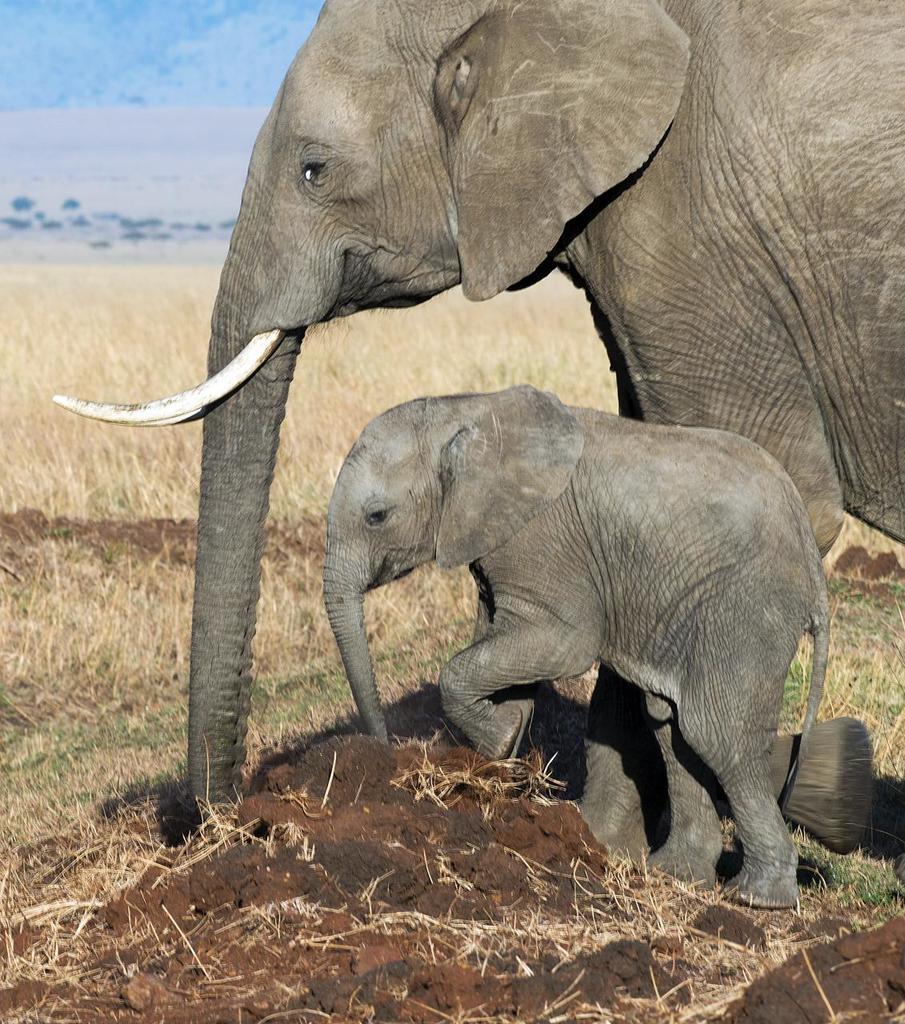Please provide a concise description of this image. In this picture there is a baby elephant who is standing near to the big elephant who is having a white teeth. At the bottom I can see the grass. In the background I can see the trees and mountain. 